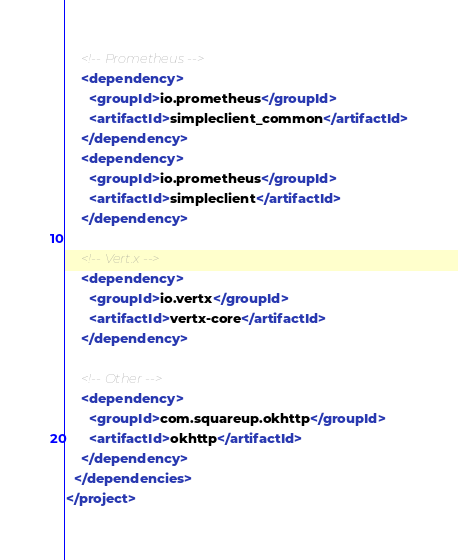Convert code to text. <code><loc_0><loc_0><loc_500><loc_500><_XML_>    <!-- Prometheus -->
    <dependency>
      <groupId>io.prometheus</groupId>
      <artifactId>simpleclient_common</artifactId>
    </dependency>
    <dependency>
      <groupId>io.prometheus</groupId>
      <artifactId>simpleclient</artifactId>
    </dependency>

    <!-- Vert.x -->
    <dependency>
      <groupId>io.vertx</groupId>
      <artifactId>vertx-core</artifactId>
    </dependency>

    <!-- Other -->
    <dependency>
      <groupId>com.squareup.okhttp</groupId>
      <artifactId>okhttp</artifactId>
    </dependency>
  </dependencies>
</project>
</code> 